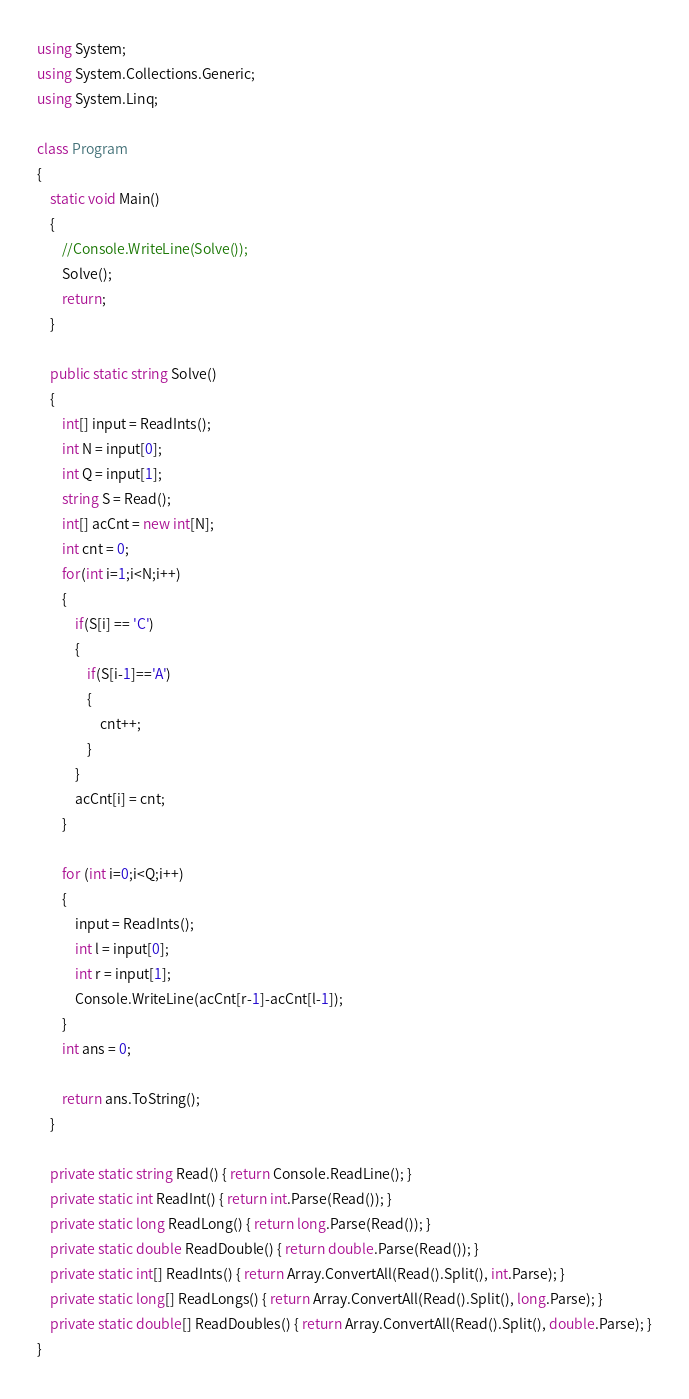<code> <loc_0><loc_0><loc_500><loc_500><_C#_>using System;
using System.Collections.Generic;
using System.Linq;

class Program
{
    static void Main()
    {
        //Console.WriteLine(Solve());
        Solve();
        return;
    }

    public static string Solve()
    {
        int[] input = ReadInts();
        int N = input[0];
        int Q = input[1];
        string S = Read();
        int[] acCnt = new int[N];
        int cnt = 0;
        for(int i=1;i<N;i++)
        {
            if(S[i] == 'C')
            {
                if(S[i-1]=='A')
                {
                    cnt++;
                }
            }
            acCnt[i] = cnt;
        }

        for (int i=0;i<Q;i++)
        {
            input = ReadInts();
            int l = input[0];
            int r = input[1];
            Console.WriteLine(acCnt[r-1]-acCnt[l-1]);
        }
        int ans = 0;

        return ans.ToString();
    }

    private static string Read() { return Console.ReadLine(); }
    private static int ReadInt() { return int.Parse(Read()); }
    private static long ReadLong() { return long.Parse(Read()); }
    private static double ReadDouble() { return double.Parse(Read()); }
    private static int[] ReadInts() { return Array.ConvertAll(Read().Split(), int.Parse); }
    private static long[] ReadLongs() { return Array.ConvertAll(Read().Split(), long.Parse); }
    private static double[] ReadDoubles() { return Array.ConvertAll(Read().Split(), double.Parse); }
}
</code> 